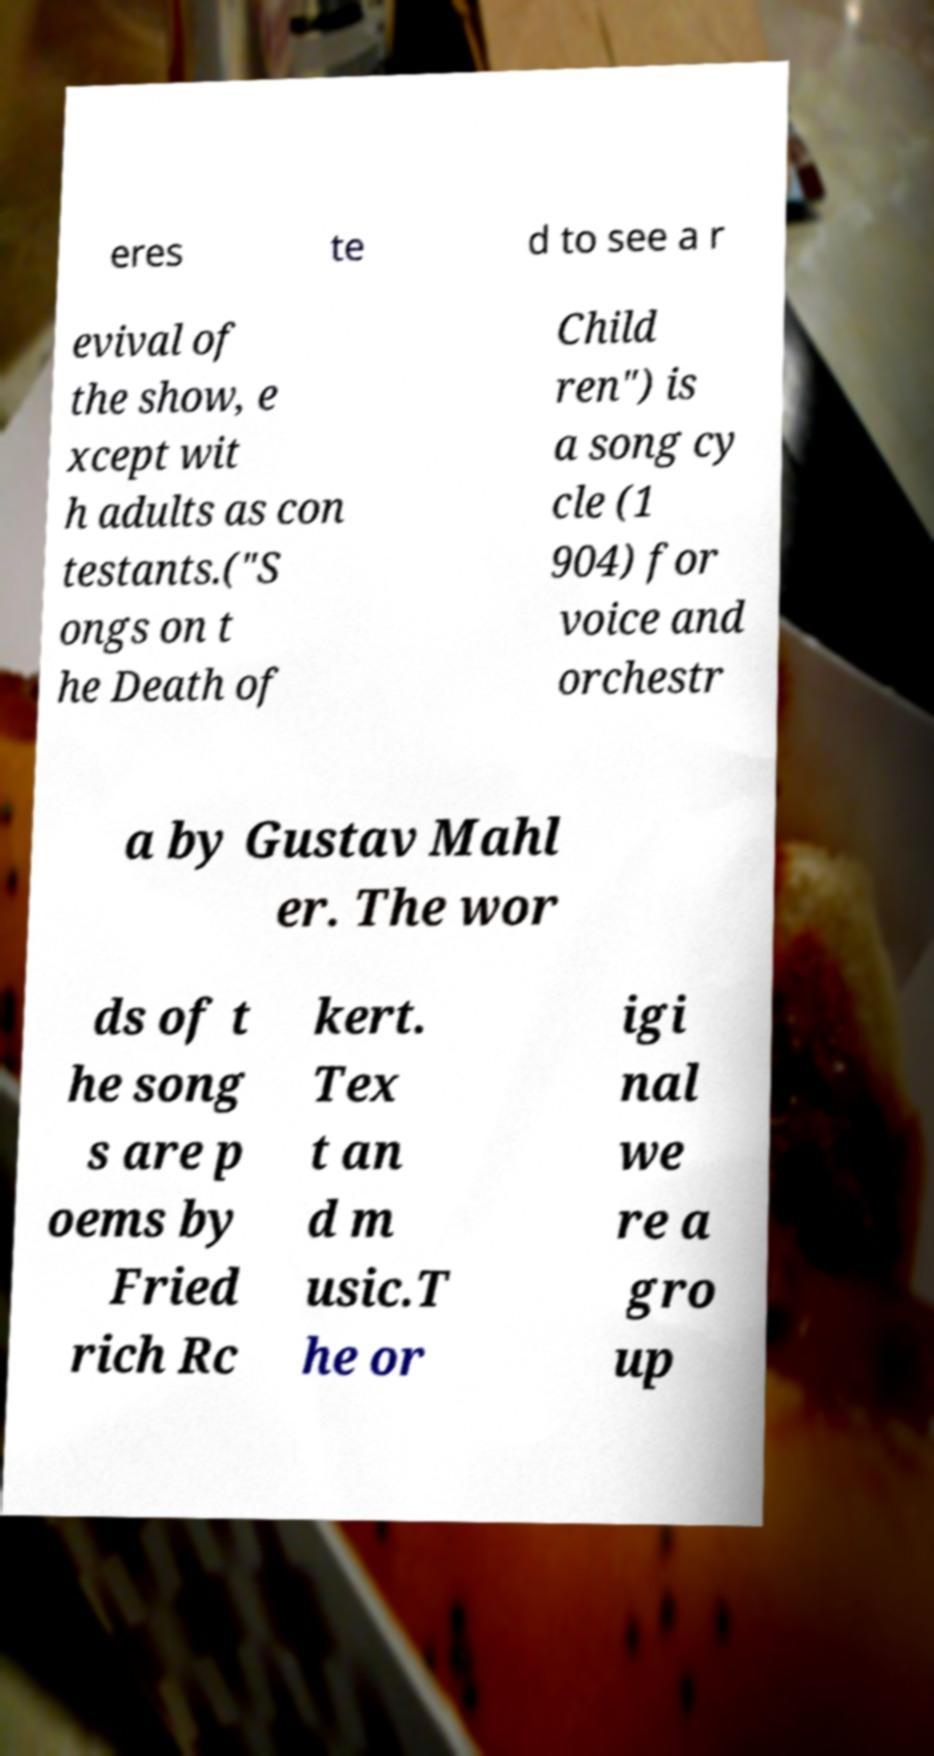Could you extract and type out the text from this image? eres te d to see a r evival of the show, e xcept wit h adults as con testants.("S ongs on t he Death of Child ren") is a song cy cle (1 904) for voice and orchestr a by Gustav Mahl er. The wor ds of t he song s are p oems by Fried rich Rc kert. Tex t an d m usic.T he or igi nal we re a gro up 